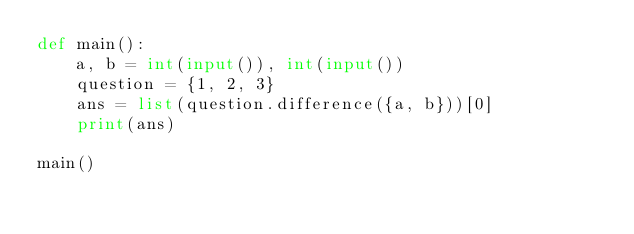<code> <loc_0><loc_0><loc_500><loc_500><_Python_>def main():
    a, b = int(input()), int(input())
    question = {1, 2, 3}
	ans = list(question.difference({a, b}))[0]
  	print(ans)

main()
</code> 